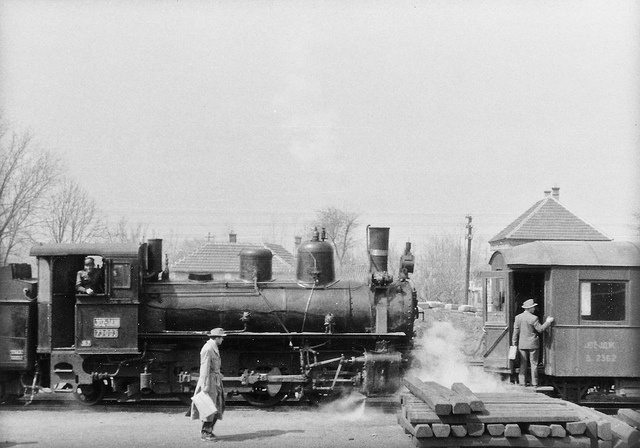Describe the objects in this image and their specific colors. I can see train in lightgray, black, gray, and darkgray tones, people in lightgray, gray, darkgray, and black tones, people in lightgray, darkgray, gray, and black tones, people in lightgray, black, darkgray, and gray tones, and handbag in lightgray, gainsboro, darkgray, gray, and black tones in this image. 